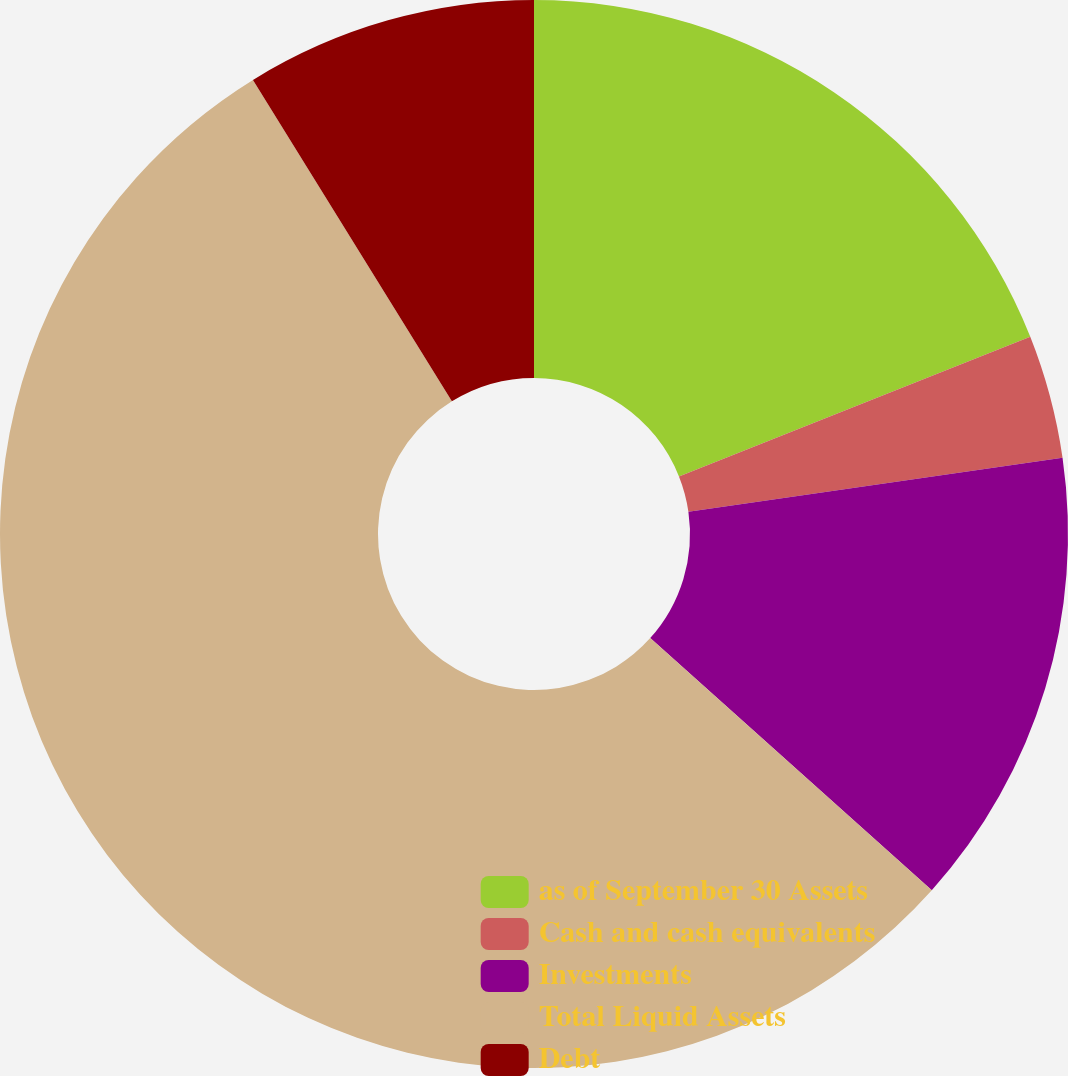<chart> <loc_0><loc_0><loc_500><loc_500><pie_chart><fcel>as of September 30 Assets<fcel>Cash and cash equivalents<fcel>Investments<fcel>Total Liquid Assets<fcel>Debt<nl><fcel>18.98%<fcel>3.74%<fcel>13.9%<fcel>54.55%<fcel>8.82%<nl></chart> 